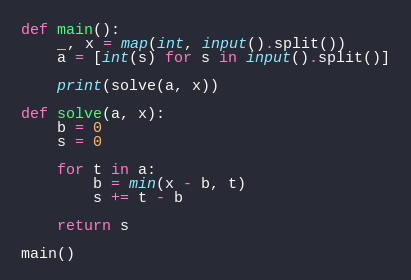<code> <loc_0><loc_0><loc_500><loc_500><_Python_>def main():
    _, x = map(int, input().split())
    a = [int(s) for s in input().split()]

    print(solve(a, x))

def solve(a, x):
    b = 0
    s = 0

    for t in a:
        b = min(x - b, t)
        s += t - b
    
    return s

main()
</code> 